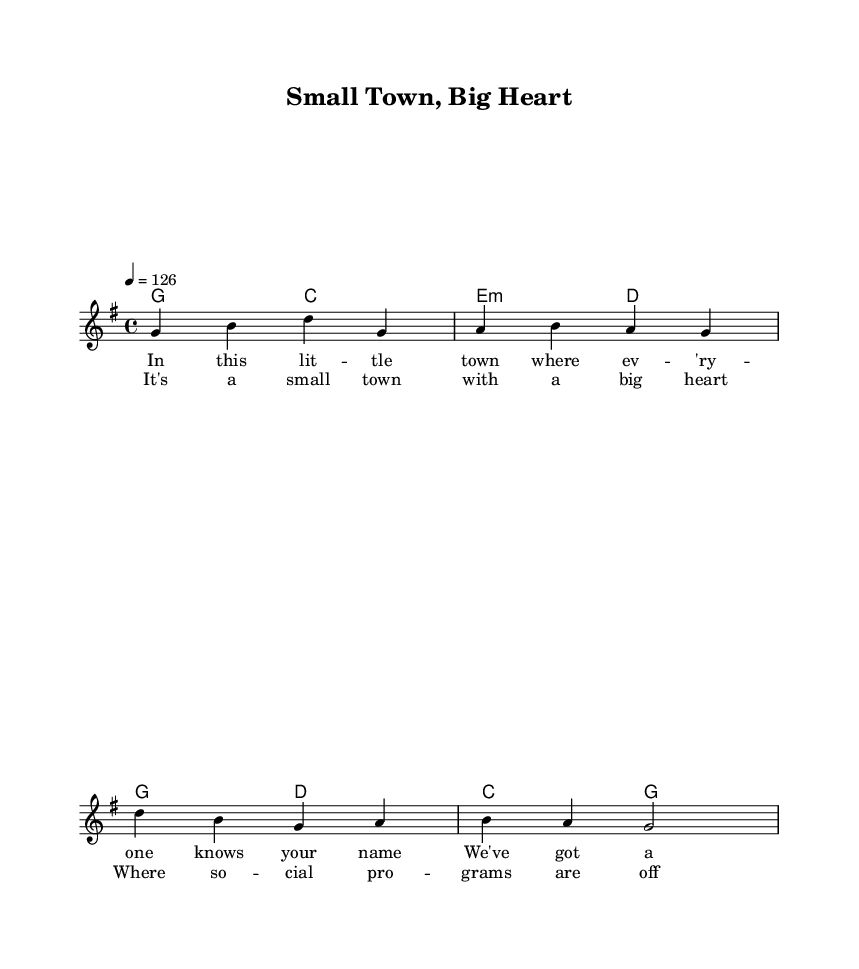What is the key signature of this music? The key signature is identified by the placement of sharps or flats at the beginning of the staff. In this case, there are no sharps or flats indicated, signifying that it is in G major.
Answer: G major What is the time signature of this piece? The time signature is indicated at the beginning of the staff with a fraction form that tells how many beats are in each measure. Here, it shows 4 over 4, meaning there are four beats per measure.
Answer: 4/4 What is the tempo marking for this piece? The tempo is indicated at the start of the piece, specifying the speed of the music. In this case, it states "4 = 126", which means there are 126 beats per minute.
Answer: 126 How many measures are in the verse? The verse consists of two lines of music and each line has two measures. Therefore, by counting the measures shown in the verse section, we find a total of four measures.
Answer: 4 What is the lyrical theme of the chorus? The chorus lyrics express a sentiment about the positive impact of social programs in a small town. Analyzing the text reveals a focus on community and support.
Answer: Small town, big heart What type of harmony is used in the verse section? The harmony in the verse section uses a mix of major and minor chords, evident from the progression shown in the chord mode. The first chord is G major, followed by C major and then E minor and D major, creating a blend of tonality.
Answer: Major and minor What musical style does this piece represent? The overall characteristics of the melody, lyrics, and instrumentation point towards a blend of country and rock influences. The upbeat rhythm and lyrical content are typical of country rock.
Answer: Country rock 